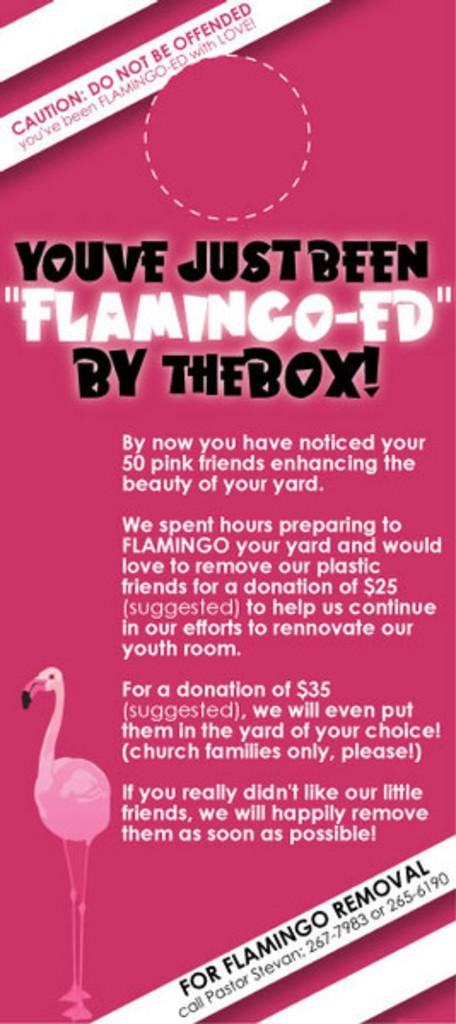What color is the poster in the image? The poster in the image is pink in color. What else can be seen on the poster besides its color? There is text on the poster. What type of image is depicted on the poster? There is a bird depicted on the poster. What type of protest is taking place in the image? There is no protest present in the image; it features a pink poster with text and a bird image. Is there a scarf visible on the bird in the image? There is no scarf present on the bird in the image; it is depicted as a static image on the poster. 